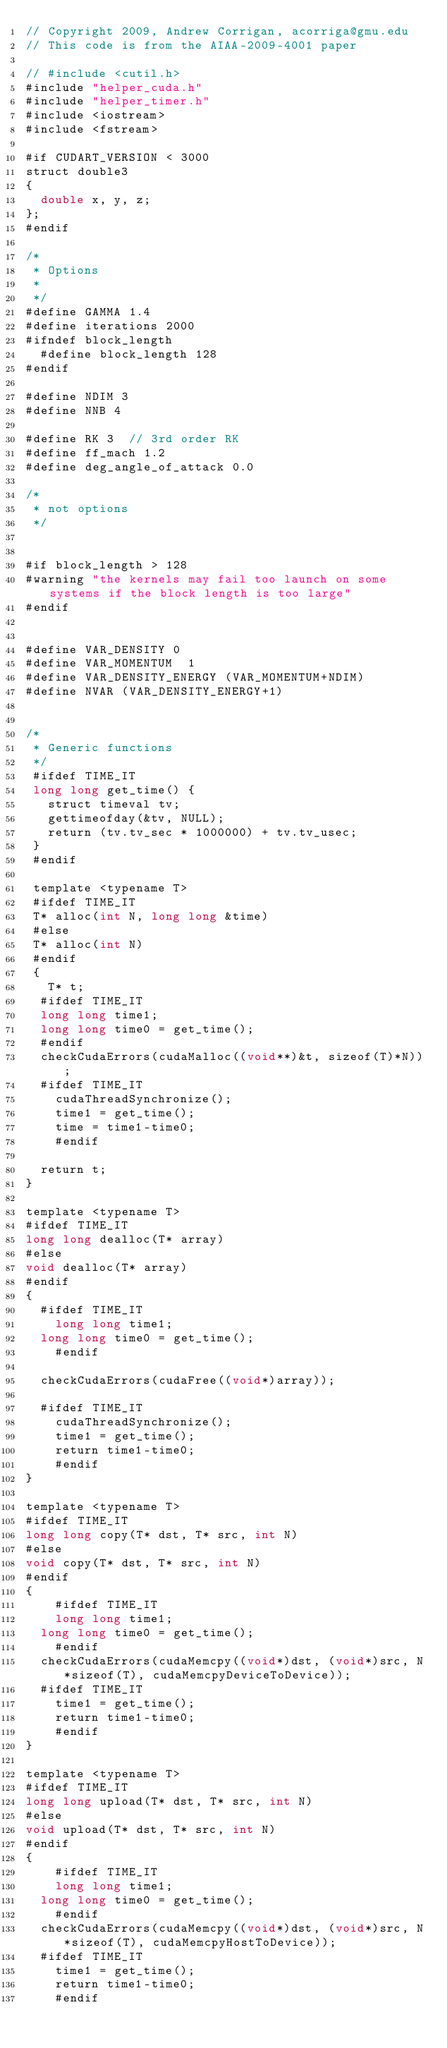<code> <loc_0><loc_0><loc_500><loc_500><_Cuda_>// Copyright 2009, Andrew Corrigan, acorriga@gmu.edu
// This code is from the AIAA-2009-4001 paper

// #include <cutil.h>
#include "helper_cuda.h"
#include "helper_timer.h"
#include <iostream>
#include <fstream>

#if CUDART_VERSION < 3000
struct double3
{
	double x, y, z;
};
#endif

/*
 * Options 
 * 
 */ 
#define GAMMA 1.4
#define iterations 2000
#ifndef block_length
	#define block_length 128
#endif

#define NDIM 3
#define NNB 4

#define RK 3	// 3rd order RK
#define ff_mach 1.2
#define deg_angle_of_attack 0.0

/*
 * not options
 */


#if block_length > 128
#warning "the kernels may fail too launch on some systems if the block length is too large"
#endif


#define VAR_DENSITY 0
#define VAR_MOMENTUM  1
#define VAR_DENSITY_ENERGY (VAR_MOMENTUM+NDIM)
#define NVAR (VAR_DENSITY_ENERGY+1)


/*
 * Generic functions
 */
 #ifdef TIME_IT
 long long get_time() {
	 struct timeval tv;
	 gettimeofday(&tv, NULL);
	 return (tv.tv_sec * 1000000) + tv.tv_usec;
 }
 #endif
 
 template <typename T>
 #ifdef TIME_IT
 T* alloc(int N, long long &time)
 #else
 T* alloc(int N)
 #endif
 {
	 T* t;
	#ifdef TIME_IT
	long long time1;
	long long time0 = get_time();
	#endif
	checkCudaErrors(cudaMalloc((void**)&t, sizeof(T)*N));
	#ifdef TIME_IT
    cudaThreadSynchronize();
    time1 = get_time();
    time = time1-time0;
    #endif

	return t;
}

template <typename T>
#ifdef TIME_IT
long long dealloc(T* array)
#else
void dealloc(T* array)
#endif
{
	#ifdef TIME_IT
  	long long time1;
	long long time0 = get_time();
    #endif

	checkCudaErrors(cudaFree((void*)array));

	#ifdef TIME_IT
    cudaThreadSynchronize();
    time1 = get_time();
    return time1-time0;
    #endif
}

template <typename T>
#ifdef TIME_IT
long long copy(T* dst, T* src, int N)
#else
void copy(T* dst, T* src, int N)
#endif
{
    #ifdef TIME_IT
  	long long time1;
	long long time0 = get_time();
    #endif
	checkCudaErrors(cudaMemcpy((void*)dst, (void*)src, N*sizeof(T), cudaMemcpyDeviceToDevice));
	#ifdef TIME_IT
    time1 = get_time();
    return time1-time0;
    #endif
}

template <typename T>
#ifdef TIME_IT
long long upload(T* dst, T* src, int N)
#else
void upload(T* dst, T* src, int N)
#endif
{
    #ifdef TIME_IT
  	long long time1;
	long long time0 = get_time();
    #endif
	checkCudaErrors(cudaMemcpy((void*)dst, (void*)src, N*sizeof(T), cudaMemcpyHostToDevice));
	#ifdef TIME_IT
    time1 = get_time();
    return time1-time0;
    #endif</code> 